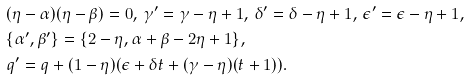<formula> <loc_0><loc_0><loc_500><loc_500>& ( \eta - \alpha ) ( \eta - \beta ) = 0 , \, \gamma ^ { \prime } = \gamma - \eta + 1 , \, \delta ^ { \prime } = \delta - \eta + 1 , \, \epsilon ^ { \prime } = \epsilon - \eta + 1 , \\ & \{ \alpha ^ { \prime } , \beta ^ { \prime } \} = \{ 2 - \eta , \alpha + \beta - 2 \eta + 1 \} , \\ & q ^ { \prime } = q + ( 1 - \eta ) ( \epsilon + \delta t + ( \gamma - \eta ) ( t + 1 ) ) .</formula> 